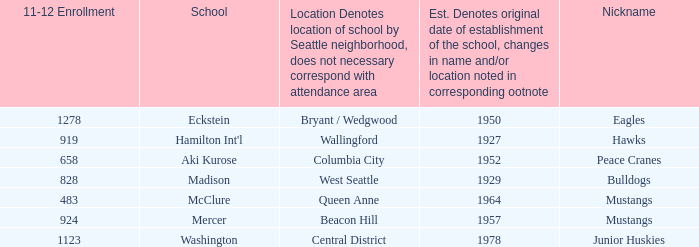Name the school for columbia city Aki Kurose. Could you parse the entire table as a dict? {'header': ['11-12 Enrollment', 'School', 'Location Denotes location of school by Seattle neighborhood, does not necessary correspond with attendance area', 'Est. Denotes original date of establishment of the school, changes in name and/or location noted in corresponding ootnote', 'Nickname'], 'rows': [['1278', 'Eckstein', 'Bryant / Wedgwood', '1950', 'Eagles'], ['919', "Hamilton Int'l", 'Wallingford', '1927', 'Hawks'], ['658', 'Aki Kurose', 'Columbia City', '1952', 'Peace Cranes'], ['828', 'Madison', 'West Seattle', '1929', 'Bulldogs'], ['483', 'McClure', 'Queen Anne', '1964', 'Mustangs'], ['924', 'Mercer', 'Beacon Hill', '1957', 'Mustangs'], ['1123', 'Washington', 'Central District', '1978', 'Junior Huskies']]} 